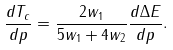<formula> <loc_0><loc_0><loc_500><loc_500>\frac { d T _ { c } } { d p } = \frac { 2 w _ { 1 } } { 5 w _ { 1 } + 4 w _ { 2 } } \frac { d \Delta E } { d p } .</formula> 